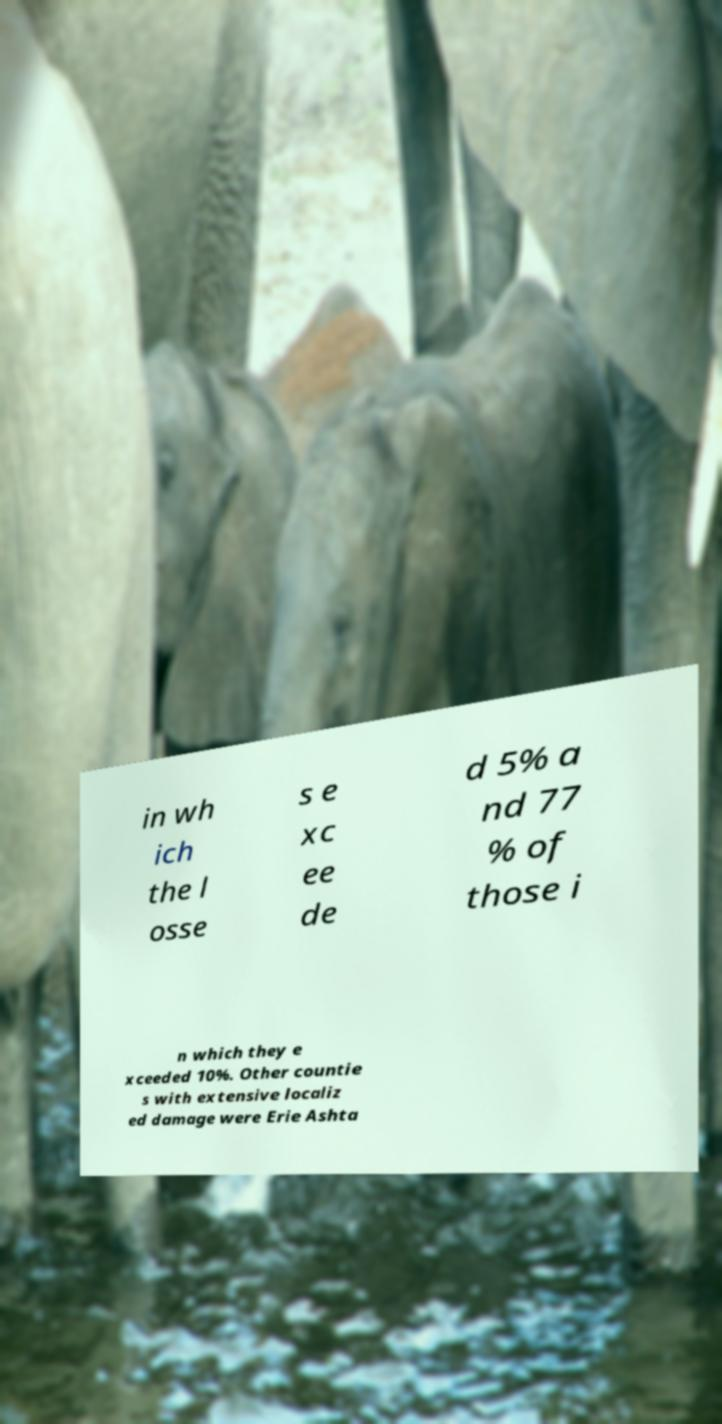Can you accurately transcribe the text from the provided image for me? in wh ich the l osse s e xc ee de d 5% a nd 77 % of those i n which they e xceeded 10%. Other countie s with extensive localiz ed damage were Erie Ashta 